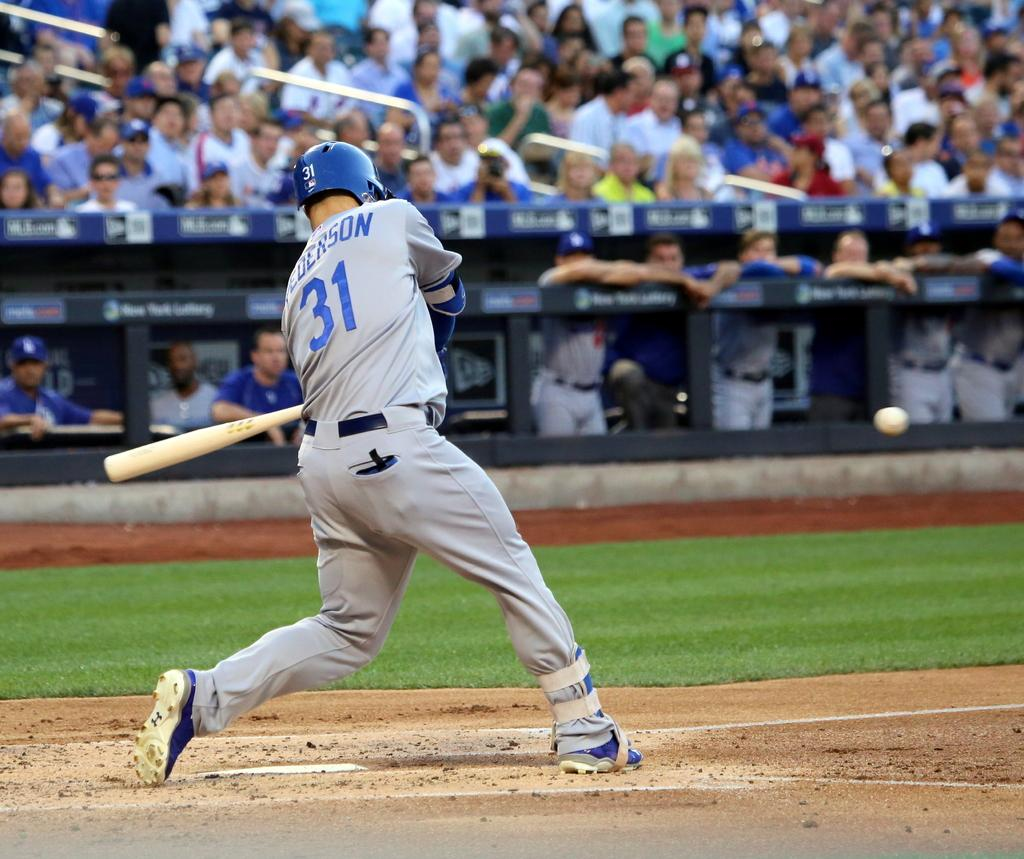<image>
Write a terse but informative summary of the picture. Number 31 is printed on the back of the batters head helmet 